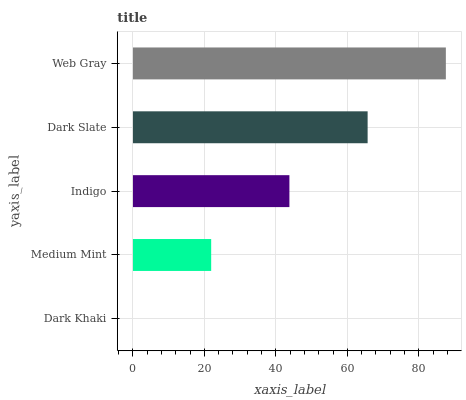Is Dark Khaki the minimum?
Answer yes or no. Yes. Is Web Gray the maximum?
Answer yes or no. Yes. Is Medium Mint the minimum?
Answer yes or no. No. Is Medium Mint the maximum?
Answer yes or no. No. Is Medium Mint greater than Dark Khaki?
Answer yes or no. Yes. Is Dark Khaki less than Medium Mint?
Answer yes or no. Yes. Is Dark Khaki greater than Medium Mint?
Answer yes or no. No. Is Medium Mint less than Dark Khaki?
Answer yes or no. No. Is Indigo the high median?
Answer yes or no. Yes. Is Indigo the low median?
Answer yes or no. Yes. Is Web Gray the high median?
Answer yes or no. No. Is Dark Slate the low median?
Answer yes or no. No. 